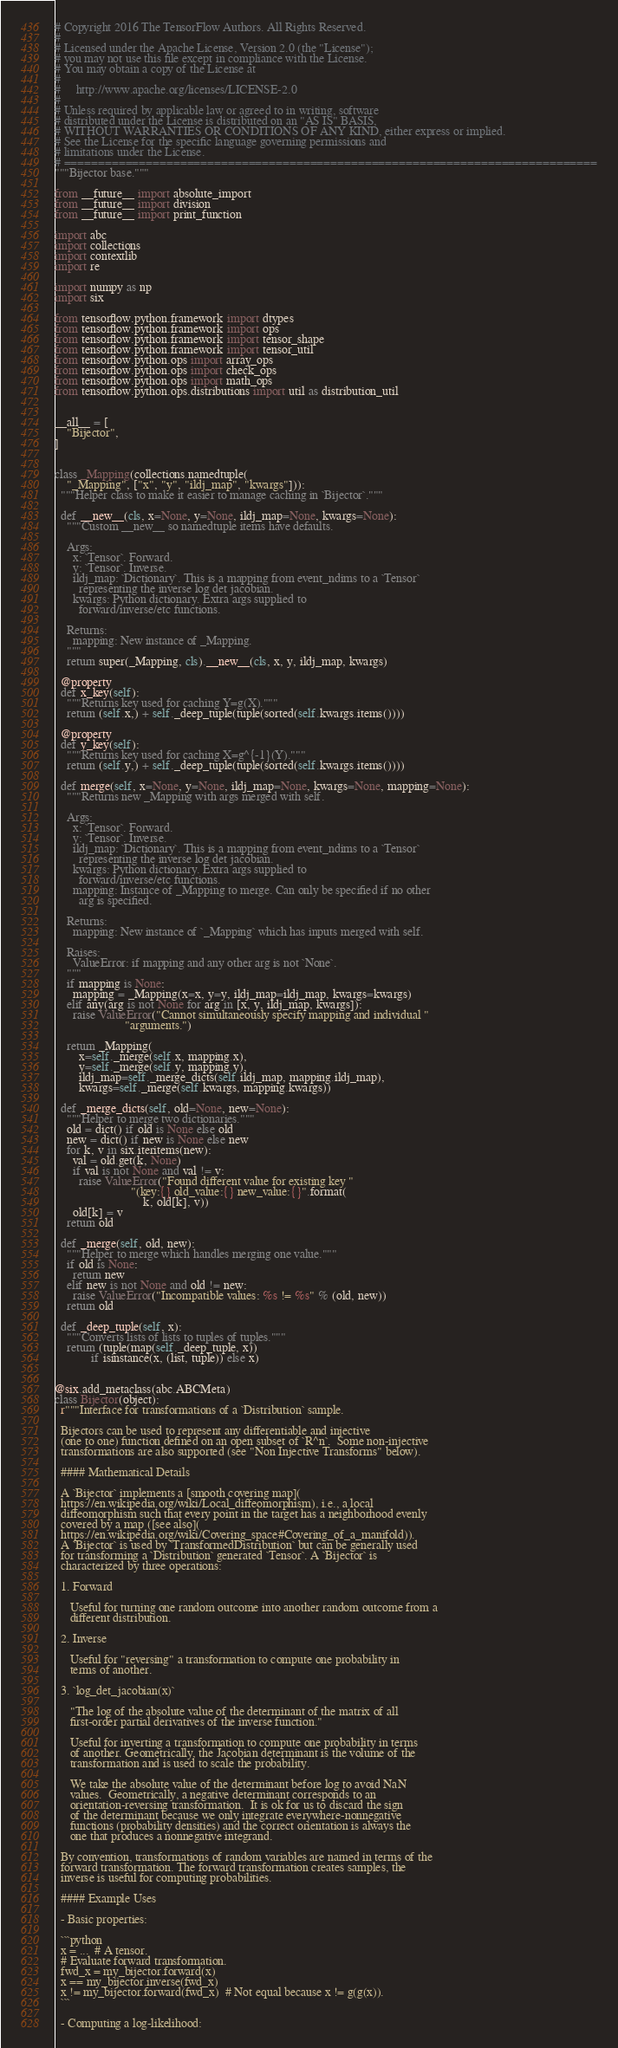<code> <loc_0><loc_0><loc_500><loc_500><_Python_># Copyright 2016 The TensorFlow Authors. All Rights Reserved.
#
# Licensed under the Apache License, Version 2.0 (the "License");
# you may not use this file except in compliance with the License.
# You may obtain a copy of the License at
#
#     http://www.apache.org/licenses/LICENSE-2.0
#
# Unless required by applicable law or agreed to in writing, software
# distributed under the License is distributed on an "AS IS" BASIS,
# WITHOUT WARRANTIES OR CONDITIONS OF ANY KIND, either express or implied.
# See the License for the specific language governing permissions and
# limitations under the License.
# ==============================================================================
"""Bijector base."""

from __future__ import absolute_import
from __future__ import division
from __future__ import print_function

import abc
import collections
import contextlib
import re

import numpy as np
import six

from tensorflow.python.framework import dtypes
from tensorflow.python.framework import ops
from tensorflow.python.framework import tensor_shape
from tensorflow.python.framework import tensor_util
from tensorflow.python.ops import array_ops
from tensorflow.python.ops import check_ops
from tensorflow.python.ops import math_ops
from tensorflow.python.ops.distributions import util as distribution_util


__all__ = [
    "Bijector",
]


class _Mapping(collections.namedtuple(
    "_Mapping", ["x", "y", "ildj_map", "kwargs"])):
  """Helper class to make it easier to manage caching in `Bijector`."""

  def __new__(cls, x=None, y=None, ildj_map=None, kwargs=None):
    """Custom __new__ so namedtuple items have defaults.

    Args:
      x: `Tensor`. Forward.
      y: `Tensor`. Inverse.
      ildj_map: `Dictionary`. This is a mapping from event_ndims to a `Tensor`
        representing the inverse log det jacobian.
      kwargs: Python dictionary. Extra args supplied to
        forward/inverse/etc functions.

    Returns:
      mapping: New instance of _Mapping.
    """
    return super(_Mapping, cls).__new__(cls, x, y, ildj_map, kwargs)

  @property
  def x_key(self):
    """Returns key used for caching Y=g(X)."""
    return (self.x,) + self._deep_tuple(tuple(sorted(self.kwargs.items())))

  @property
  def y_key(self):
    """Returns key used for caching X=g^{-1}(Y)."""
    return (self.y,) + self._deep_tuple(tuple(sorted(self.kwargs.items())))

  def merge(self, x=None, y=None, ildj_map=None, kwargs=None, mapping=None):
    """Returns new _Mapping with args merged with self.

    Args:
      x: `Tensor`. Forward.
      y: `Tensor`. Inverse.
      ildj_map: `Dictionary`. This is a mapping from event_ndims to a `Tensor`
        representing the inverse log det jacobian.
      kwargs: Python dictionary. Extra args supplied to
        forward/inverse/etc functions.
      mapping: Instance of _Mapping to merge. Can only be specified if no other
        arg is specified.

    Returns:
      mapping: New instance of `_Mapping` which has inputs merged with self.

    Raises:
      ValueError: if mapping and any other arg is not `None`.
    """
    if mapping is None:
      mapping = _Mapping(x=x, y=y, ildj_map=ildj_map, kwargs=kwargs)
    elif any(arg is not None for arg in [x, y, ildj_map, kwargs]):
      raise ValueError("Cannot simultaneously specify mapping and individual "
                       "arguments.")

    return _Mapping(
        x=self._merge(self.x, mapping.x),
        y=self._merge(self.y, mapping.y),
        ildj_map=self._merge_dicts(self.ildj_map, mapping.ildj_map),
        kwargs=self._merge(self.kwargs, mapping.kwargs))

  def _merge_dicts(self, old=None, new=None):
    """Helper to merge two dictionaries."""
    old = dict() if old is None else old
    new = dict() if new is None else new
    for k, v in six.iteritems(new):
      val = old.get(k, None)
      if val is not None and val != v:
        raise ValueError("Found different value for existing key "
                         "(key:{} old_value:{} new_value:{}".format(
                             k, old[k], v))
      old[k] = v
    return old

  def _merge(self, old, new):
    """Helper to merge which handles merging one value."""
    if old is None:
      return new
    elif new is not None and old != new:
      raise ValueError("Incompatible values: %s != %s" % (old, new))
    return old

  def _deep_tuple(self, x):
    """Converts lists of lists to tuples of tuples."""
    return (tuple(map(self._deep_tuple, x))
            if isinstance(x, (list, tuple)) else x)


@six.add_metaclass(abc.ABCMeta)
class Bijector(object):
  r"""Interface for transformations of a `Distribution` sample.

  Bijectors can be used to represent any differentiable and injective
  (one to one) function defined on an open subset of `R^n`.  Some non-injective
  transformations are also supported (see "Non Injective Transforms" below).

  #### Mathematical Details

  A `Bijector` implements a [smooth covering map](
  https://en.wikipedia.org/wiki/Local_diffeomorphism), i.e., a local
  diffeomorphism such that every point in the target has a neighborhood evenly
  covered by a map ([see also](
  https://en.wikipedia.org/wiki/Covering_space#Covering_of_a_manifold)).
  A `Bijector` is used by `TransformedDistribution` but can be generally used
  for transforming a `Distribution` generated `Tensor`. A `Bijector` is
  characterized by three operations:

  1. Forward

     Useful for turning one random outcome into another random outcome from a
     different distribution.

  2. Inverse

     Useful for "reversing" a transformation to compute one probability in
     terms of another.

  3. `log_det_jacobian(x)`

     "The log of the absolute value of the determinant of the matrix of all
     first-order partial derivatives of the inverse function."

     Useful for inverting a transformation to compute one probability in terms
     of another. Geometrically, the Jacobian determinant is the volume of the
     transformation and is used to scale the probability.

     We take the absolute value of the determinant before log to avoid NaN
     values.  Geometrically, a negative determinant corresponds to an
     orientation-reversing transformation.  It is ok for us to discard the sign
     of the determinant because we only integrate everywhere-nonnegative
     functions (probability densities) and the correct orientation is always the
     one that produces a nonnegative integrand.

  By convention, transformations of random variables are named in terms of the
  forward transformation. The forward transformation creates samples, the
  inverse is useful for computing probabilities.

  #### Example Uses

  - Basic properties:

  ```python
  x = ...  # A tensor.
  # Evaluate forward transformation.
  fwd_x = my_bijector.forward(x)
  x == my_bijector.inverse(fwd_x)
  x != my_bijector.forward(fwd_x)  # Not equal because x != g(g(x)).
  ```

  - Computing a log-likelihood:
</code> 